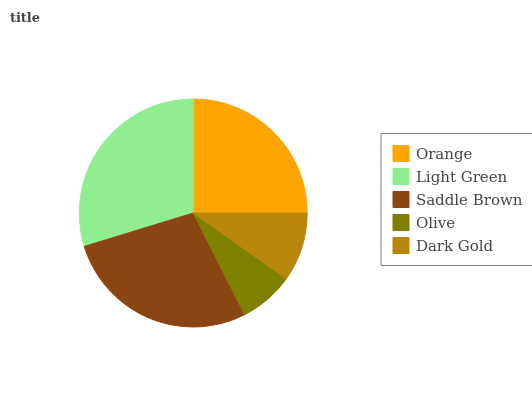Is Olive the minimum?
Answer yes or no. Yes. Is Light Green the maximum?
Answer yes or no. Yes. Is Saddle Brown the minimum?
Answer yes or no. No. Is Saddle Brown the maximum?
Answer yes or no. No. Is Light Green greater than Saddle Brown?
Answer yes or no. Yes. Is Saddle Brown less than Light Green?
Answer yes or no. Yes. Is Saddle Brown greater than Light Green?
Answer yes or no. No. Is Light Green less than Saddle Brown?
Answer yes or no. No. Is Orange the high median?
Answer yes or no. Yes. Is Orange the low median?
Answer yes or no. Yes. Is Dark Gold the high median?
Answer yes or no. No. Is Olive the low median?
Answer yes or no. No. 